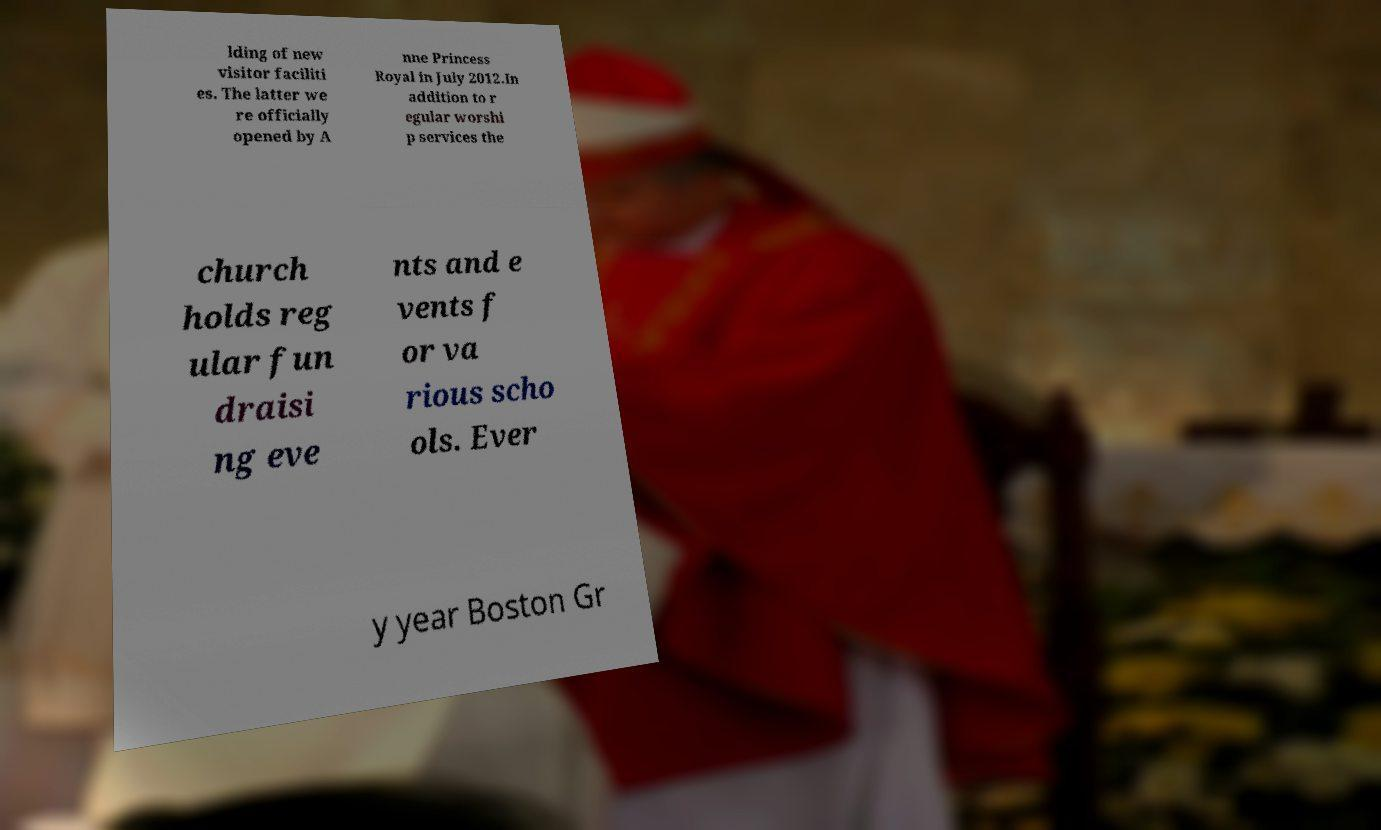Can you read and provide the text displayed in the image?This photo seems to have some interesting text. Can you extract and type it out for me? lding of new visitor faciliti es. The latter we re officially opened by A nne Princess Royal in July 2012.In addition to r egular worshi p services the church holds reg ular fun draisi ng eve nts and e vents f or va rious scho ols. Ever y year Boston Gr 